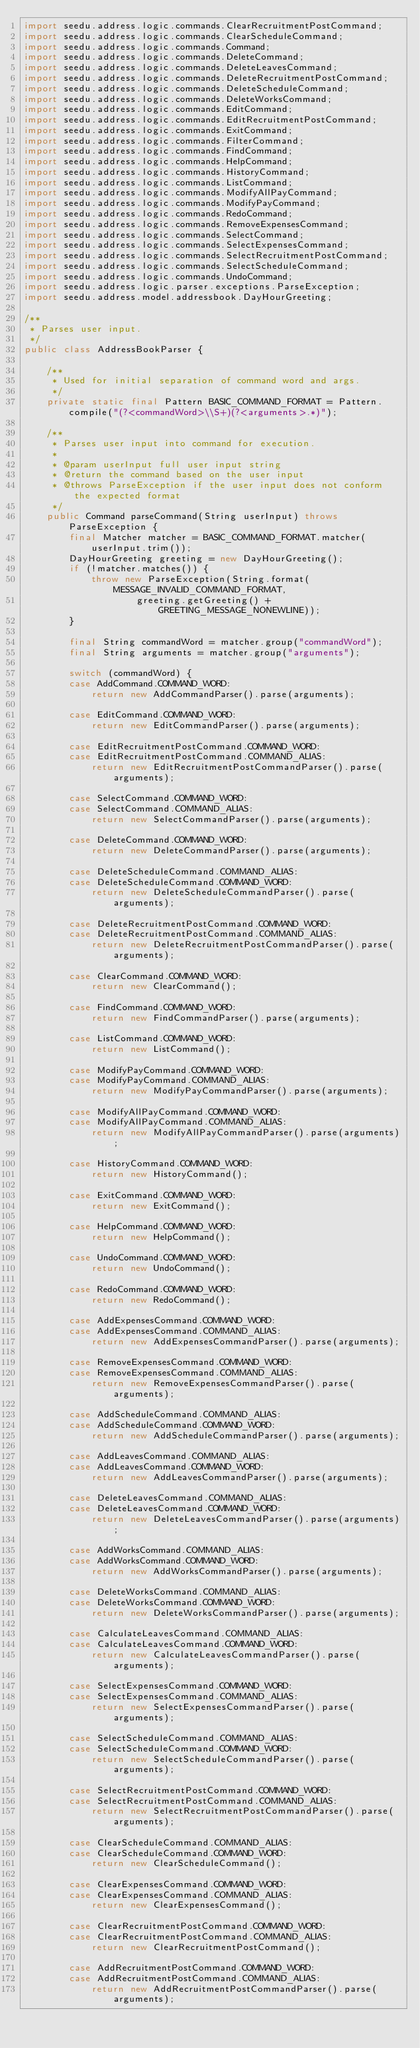<code> <loc_0><loc_0><loc_500><loc_500><_Java_>import seedu.address.logic.commands.ClearRecruitmentPostCommand;
import seedu.address.logic.commands.ClearScheduleCommand;
import seedu.address.logic.commands.Command;
import seedu.address.logic.commands.DeleteCommand;
import seedu.address.logic.commands.DeleteLeavesCommand;
import seedu.address.logic.commands.DeleteRecruitmentPostCommand;
import seedu.address.logic.commands.DeleteScheduleCommand;
import seedu.address.logic.commands.DeleteWorksCommand;
import seedu.address.logic.commands.EditCommand;
import seedu.address.logic.commands.EditRecruitmentPostCommand;
import seedu.address.logic.commands.ExitCommand;
import seedu.address.logic.commands.FilterCommand;
import seedu.address.logic.commands.FindCommand;
import seedu.address.logic.commands.HelpCommand;
import seedu.address.logic.commands.HistoryCommand;
import seedu.address.logic.commands.ListCommand;
import seedu.address.logic.commands.ModifyAllPayCommand;
import seedu.address.logic.commands.ModifyPayCommand;
import seedu.address.logic.commands.RedoCommand;
import seedu.address.logic.commands.RemoveExpensesCommand;
import seedu.address.logic.commands.SelectCommand;
import seedu.address.logic.commands.SelectExpensesCommand;
import seedu.address.logic.commands.SelectRecruitmentPostCommand;
import seedu.address.logic.commands.SelectScheduleCommand;
import seedu.address.logic.commands.UndoCommand;
import seedu.address.logic.parser.exceptions.ParseException;
import seedu.address.model.addressbook.DayHourGreeting;

/**
 * Parses user input.
 */
public class AddressBookParser {

    /**
     * Used for initial separation of command word and args.
     */
    private static final Pattern BASIC_COMMAND_FORMAT = Pattern.compile("(?<commandWord>\\S+)(?<arguments>.*)");

    /**
     * Parses user input into command for execution.
     *
     * @param userInput full user input string
     * @return the command based on the user input
     * @throws ParseException if the user input does not conform the expected format
     */
    public Command parseCommand(String userInput) throws ParseException {
        final Matcher matcher = BASIC_COMMAND_FORMAT.matcher(userInput.trim());
        DayHourGreeting greeting = new DayHourGreeting();
        if (!matcher.matches()) {
            throw new ParseException(String.format(MESSAGE_INVALID_COMMAND_FORMAT,
                    greeting.getGreeting() + GREETING_MESSAGE_NONEWLINE));
        }

        final String commandWord = matcher.group("commandWord");
        final String arguments = matcher.group("arguments");

        switch (commandWord) {
        case AddCommand.COMMAND_WORD:
            return new AddCommandParser().parse(arguments);

        case EditCommand.COMMAND_WORD:
            return new EditCommandParser().parse(arguments);

        case EditRecruitmentPostCommand.COMMAND_WORD:
        case EditRecruitmentPostCommand.COMMAND_ALIAS:
            return new EditRecruitmentPostCommandParser().parse(arguments);

        case SelectCommand.COMMAND_WORD:
        case SelectCommand.COMMAND_ALIAS:
            return new SelectCommandParser().parse(arguments);

        case DeleteCommand.COMMAND_WORD:
            return new DeleteCommandParser().parse(arguments);

        case DeleteScheduleCommand.COMMAND_ALIAS:
        case DeleteScheduleCommand.COMMAND_WORD:
            return new DeleteScheduleCommandParser().parse(arguments);

        case DeleteRecruitmentPostCommand.COMMAND_WORD:
        case DeleteRecruitmentPostCommand.COMMAND_ALIAS:
            return new DeleteRecruitmentPostCommandParser().parse(arguments);

        case ClearCommand.COMMAND_WORD:
            return new ClearCommand();

        case FindCommand.COMMAND_WORD:
            return new FindCommandParser().parse(arguments);

        case ListCommand.COMMAND_WORD:
            return new ListCommand();

        case ModifyPayCommand.COMMAND_WORD:
        case ModifyPayCommand.COMMAND_ALIAS:
            return new ModifyPayCommandParser().parse(arguments);

        case ModifyAllPayCommand.COMMAND_WORD:
        case ModifyAllPayCommand.COMMAND_ALIAS:
            return new ModifyAllPayCommandParser().parse(arguments);

        case HistoryCommand.COMMAND_WORD:
            return new HistoryCommand();

        case ExitCommand.COMMAND_WORD:
            return new ExitCommand();

        case HelpCommand.COMMAND_WORD:
            return new HelpCommand();

        case UndoCommand.COMMAND_WORD:
            return new UndoCommand();

        case RedoCommand.COMMAND_WORD:
            return new RedoCommand();

        case AddExpensesCommand.COMMAND_WORD:
        case AddExpensesCommand.COMMAND_ALIAS:
            return new AddExpensesCommandParser().parse(arguments);

        case RemoveExpensesCommand.COMMAND_WORD:
        case RemoveExpensesCommand.COMMAND_ALIAS:
            return new RemoveExpensesCommandParser().parse(arguments);

        case AddScheduleCommand.COMMAND_ALIAS:
        case AddScheduleCommand.COMMAND_WORD:
            return new AddScheduleCommandParser().parse(arguments);

        case AddLeavesCommand.COMMAND_ALIAS:
        case AddLeavesCommand.COMMAND_WORD:
            return new AddLeavesCommandParser().parse(arguments);

        case DeleteLeavesCommand.COMMAND_ALIAS:
        case DeleteLeavesCommand.COMMAND_WORD:
            return new DeleteLeavesCommandParser().parse(arguments);

        case AddWorksCommand.COMMAND_ALIAS:
        case AddWorksCommand.COMMAND_WORD:
            return new AddWorksCommandParser().parse(arguments);

        case DeleteWorksCommand.COMMAND_ALIAS:
        case DeleteWorksCommand.COMMAND_WORD:
            return new DeleteWorksCommandParser().parse(arguments);

        case CalculateLeavesCommand.COMMAND_ALIAS:
        case CalculateLeavesCommand.COMMAND_WORD:
            return new CalculateLeavesCommandParser().parse(arguments);

        case SelectExpensesCommand.COMMAND_WORD:
        case SelectExpensesCommand.COMMAND_ALIAS:
            return new SelectExpensesCommandParser().parse(arguments);

        case SelectScheduleCommand.COMMAND_ALIAS:
        case SelectScheduleCommand.COMMAND_WORD:
            return new SelectScheduleCommandParser().parse(arguments);

        case SelectRecruitmentPostCommand.COMMAND_WORD:
        case SelectRecruitmentPostCommand.COMMAND_ALIAS:
            return new SelectRecruitmentPostCommandParser().parse(arguments);

        case ClearScheduleCommand.COMMAND_ALIAS:
        case ClearScheduleCommand.COMMAND_WORD:
            return new ClearScheduleCommand();

        case ClearExpensesCommand.COMMAND_WORD:
        case ClearExpensesCommand.COMMAND_ALIAS:
            return new ClearExpensesCommand();

        case ClearRecruitmentPostCommand.COMMAND_WORD:
        case ClearRecruitmentPostCommand.COMMAND_ALIAS:
            return new ClearRecruitmentPostCommand();

        case AddRecruitmentPostCommand.COMMAND_WORD:
        case AddRecruitmentPostCommand.COMMAND_ALIAS:
            return new AddRecruitmentPostCommandParser().parse(arguments);
</code> 